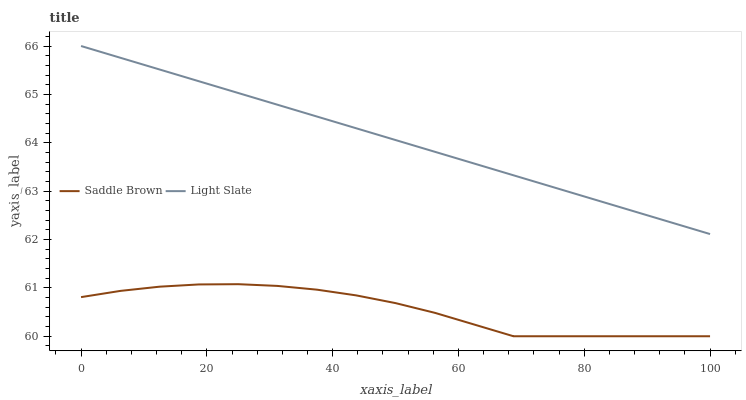Does Saddle Brown have the minimum area under the curve?
Answer yes or no. Yes. Does Light Slate have the maximum area under the curve?
Answer yes or no. Yes. Does Saddle Brown have the maximum area under the curve?
Answer yes or no. No. Is Light Slate the smoothest?
Answer yes or no. Yes. Is Saddle Brown the roughest?
Answer yes or no. Yes. Is Saddle Brown the smoothest?
Answer yes or no. No. Does Saddle Brown have the lowest value?
Answer yes or no. Yes. Does Light Slate have the highest value?
Answer yes or no. Yes. Does Saddle Brown have the highest value?
Answer yes or no. No. Is Saddle Brown less than Light Slate?
Answer yes or no. Yes. Is Light Slate greater than Saddle Brown?
Answer yes or no. Yes. Does Saddle Brown intersect Light Slate?
Answer yes or no. No. 